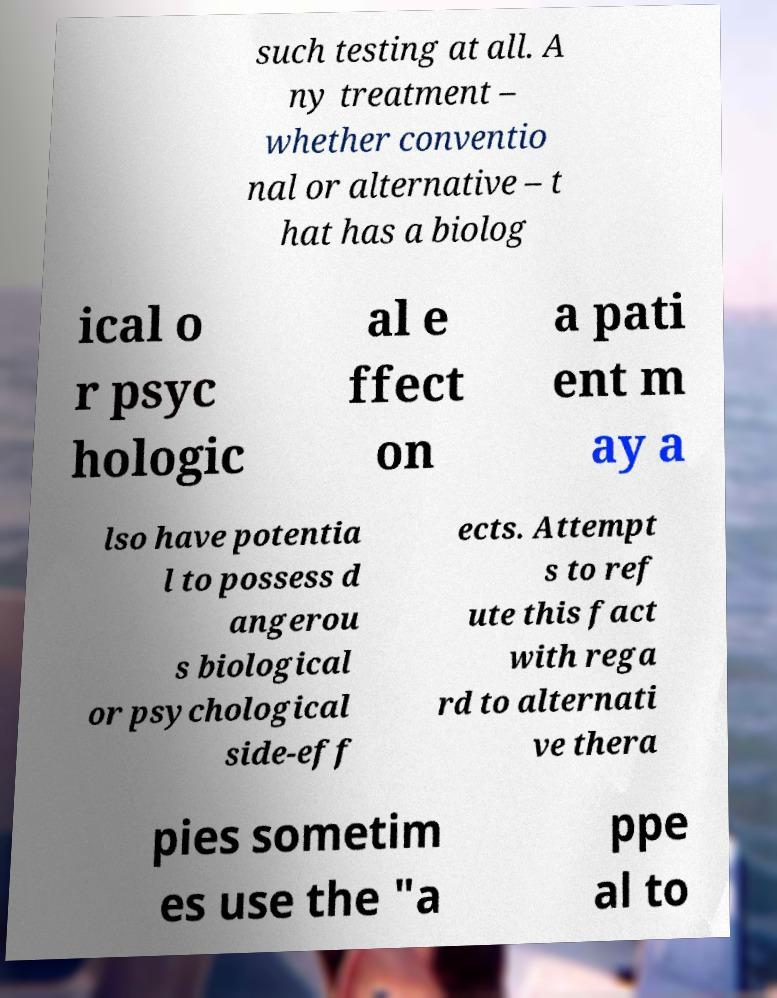For documentation purposes, I need the text within this image transcribed. Could you provide that? such testing at all. A ny treatment – whether conventio nal or alternative – t hat has a biolog ical o r psyc hologic al e ffect on a pati ent m ay a lso have potentia l to possess d angerou s biological or psychological side-eff ects. Attempt s to ref ute this fact with rega rd to alternati ve thera pies sometim es use the "a ppe al to 